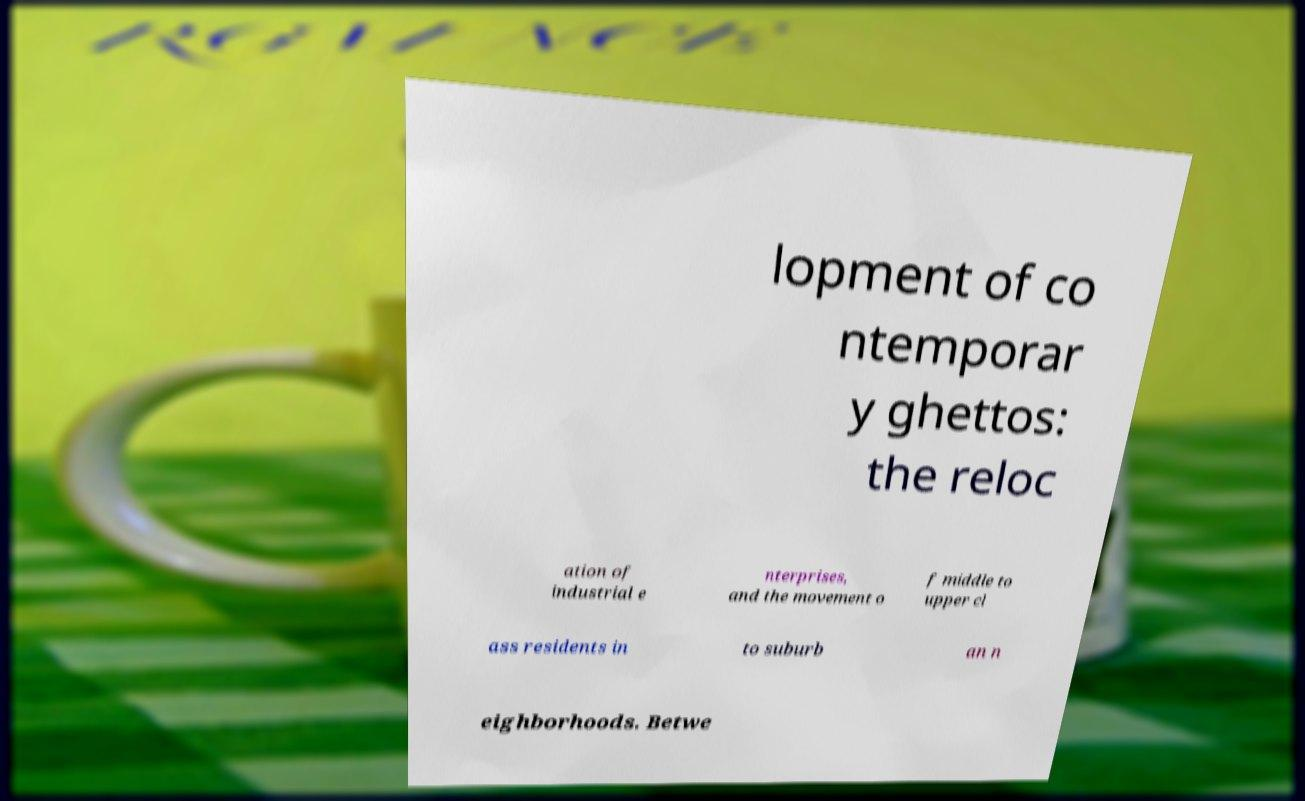What messages or text are displayed in this image? I need them in a readable, typed format. lopment of co ntemporar y ghettos: the reloc ation of industrial e nterprises, and the movement o f middle to upper cl ass residents in to suburb an n eighborhoods. Betwe 